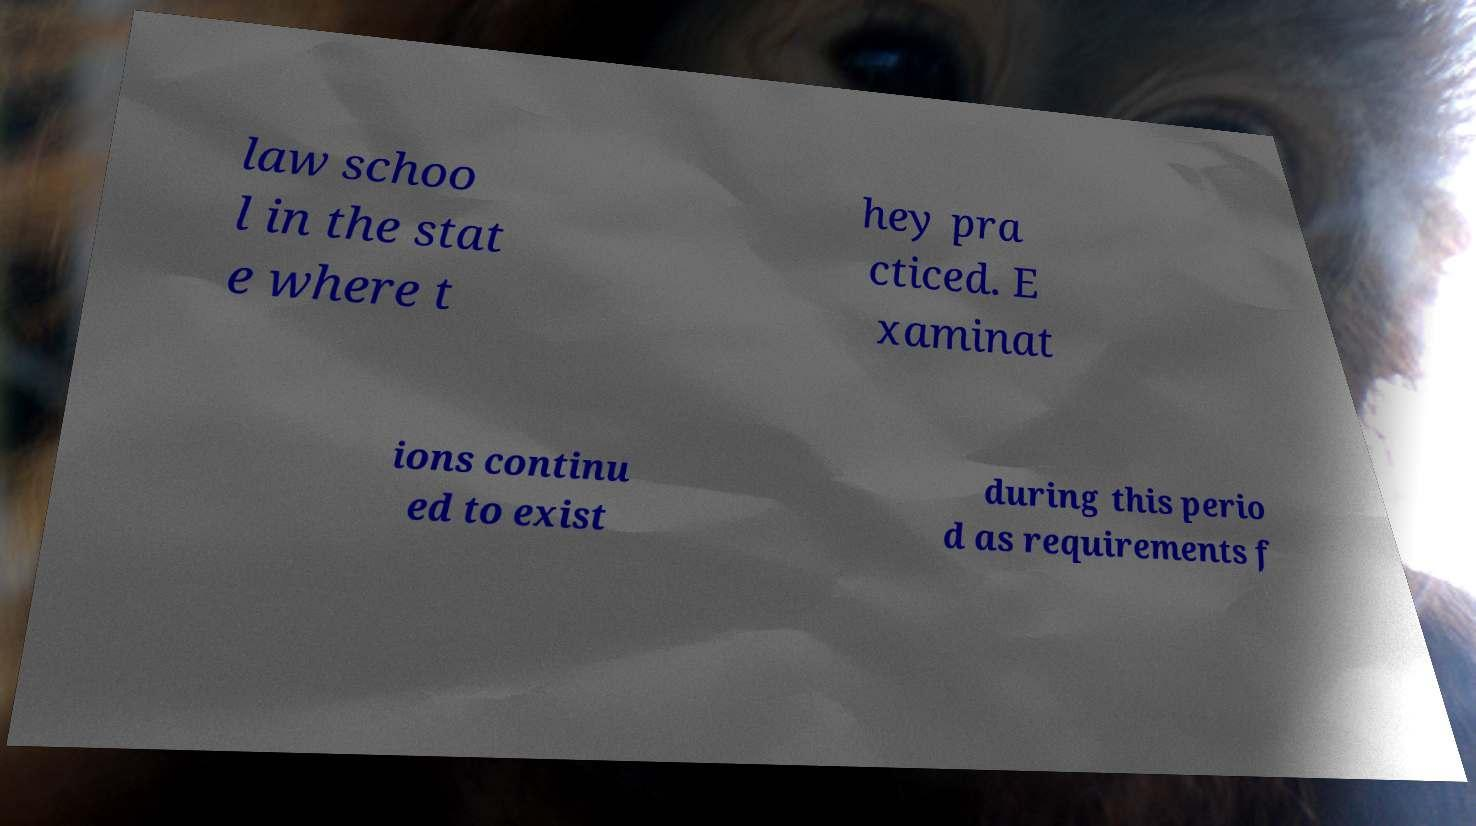I need the written content from this picture converted into text. Can you do that? law schoo l in the stat e where t hey pra cticed. E xaminat ions continu ed to exist during this perio d as requirements f 